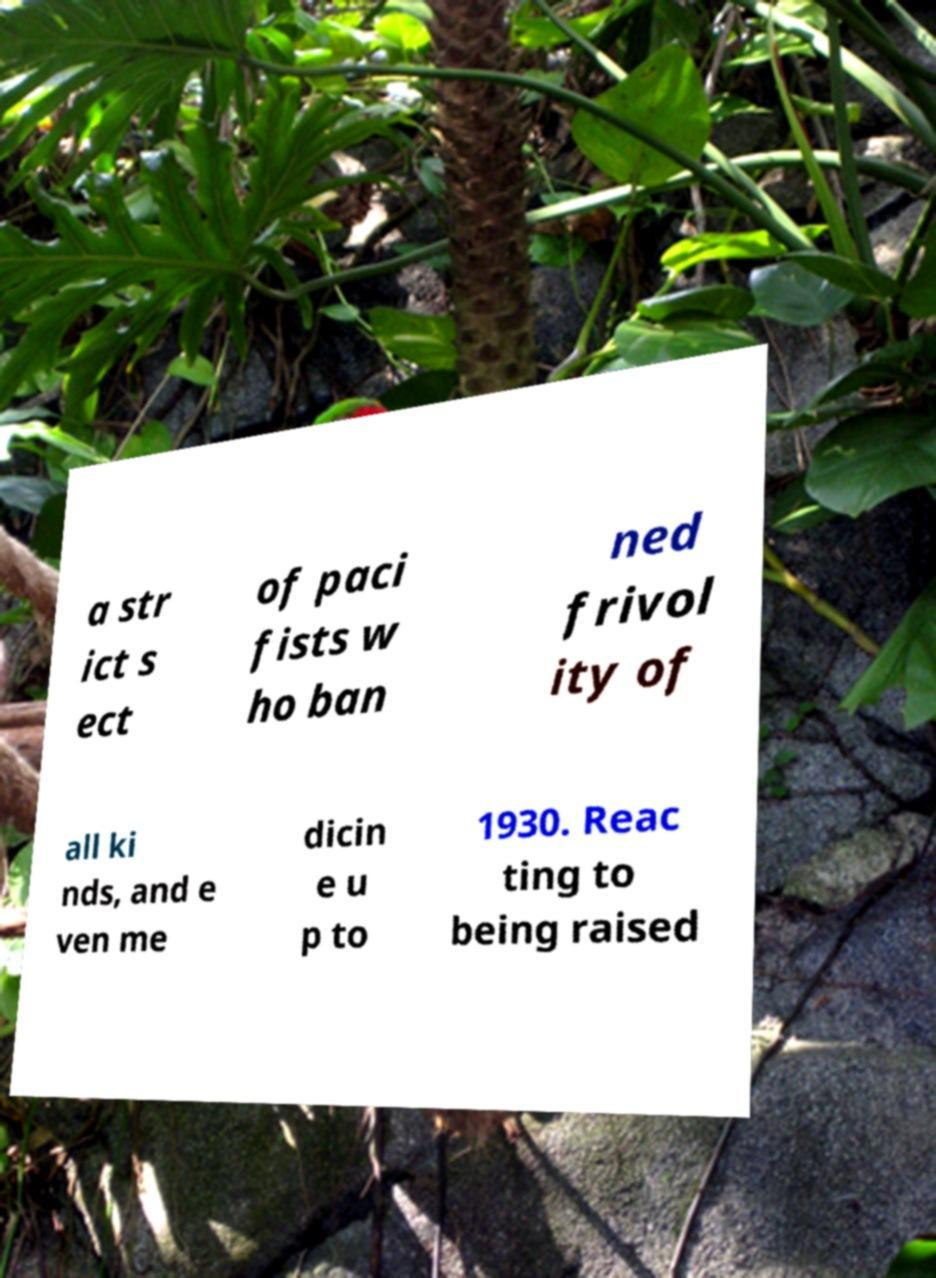Please read and relay the text visible in this image. What does it say? a str ict s ect of paci fists w ho ban ned frivol ity of all ki nds, and e ven me dicin e u p to 1930. Reac ting to being raised 